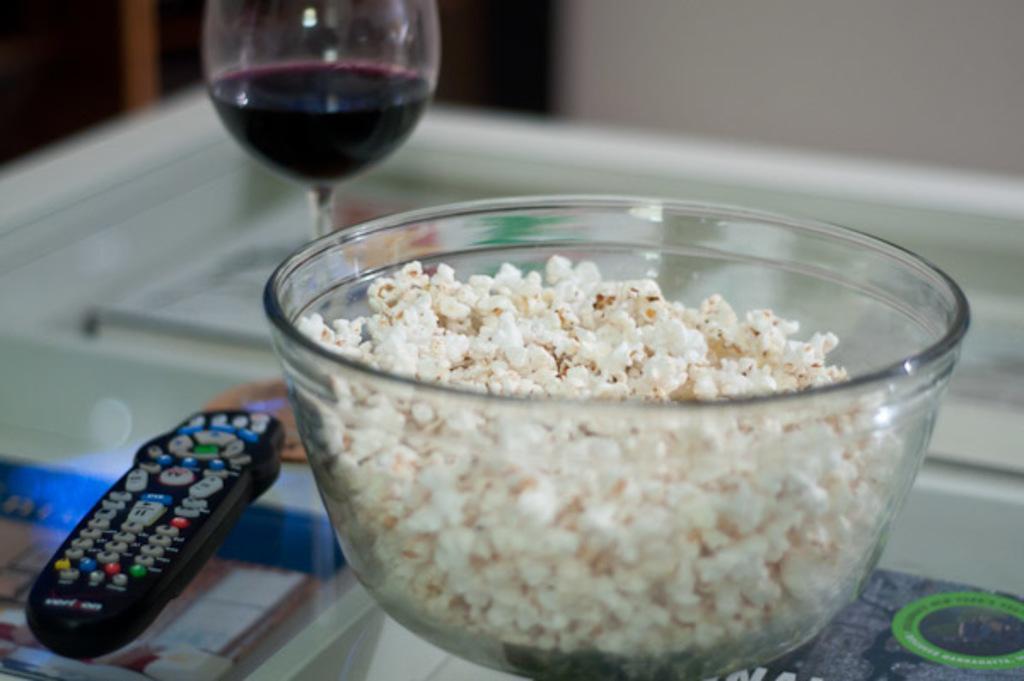How would you summarize this image in a sentence or two? In this image there is a table, on that table there is a remote, glass and a bowl in that bowl there is popcorn, in the background it is blurred. 